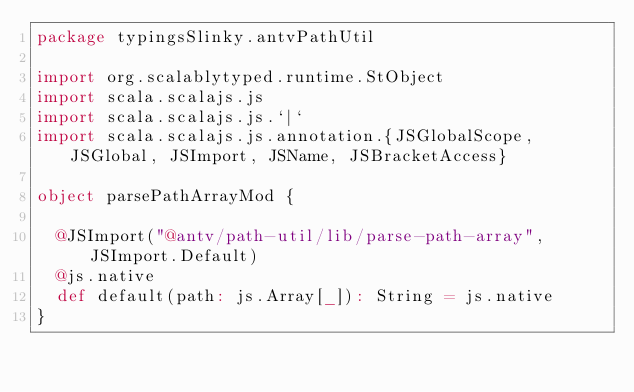<code> <loc_0><loc_0><loc_500><loc_500><_Scala_>package typingsSlinky.antvPathUtil

import org.scalablytyped.runtime.StObject
import scala.scalajs.js
import scala.scalajs.js.`|`
import scala.scalajs.js.annotation.{JSGlobalScope, JSGlobal, JSImport, JSName, JSBracketAccess}

object parsePathArrayMod {
  
  @JSImport("@antv/path-util/lib/parse-path-array", JSImport.Default)
  @js.native
  def default(path: js.Array[_]): String = js.native
}
</code> 